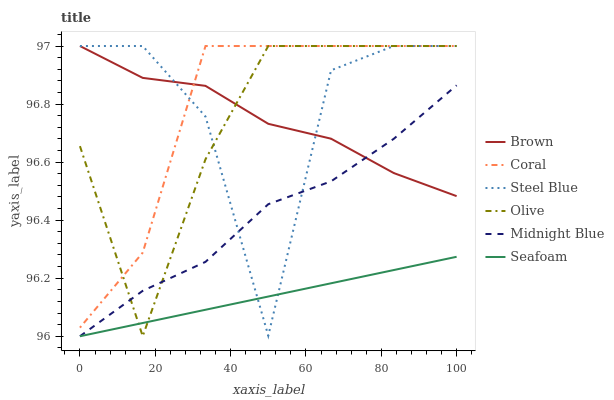Does Seafoam have the minimum area under the curve?
Answer yes or no. Yes. Does Coral have the maximum area under the curve?
Answer yes or no. Yes. Does Midnight Blue have the minimum area under the curve?
Answer yes or no. No. Does Midnight Blue have the maximum area under the curve?
Answer yes or no. No. Is Seafoam the smoothest?
Answer yes or no. Yes. Is Steel Blue the roughest?
Answer yes or no. Yes. Is Midnight Blue the smoothest?
Answer yes or no. No. Is Midnight Blue the roughest?
Answer yes or no. No. Does Midnight Blue have the lowest value?
Answer yes or no. Yes. Does Coral have the lowest value?
Answer yes or no. No. Does Olive have the highest value?
Answer yes or no. Yes. Does Midnight Blue have the highest value?
Answer yes or no. No. Is Seafoam less than Brown?
Answer yes or no. Yes. Is Coral greater than Seafoam?
Answer yes or no. Yes. Does Brown intersect Midnight Blue?
Answer yes or no. Yes. Is Brown less than Midnight Blue?
Answer yes or no. No. Is Brown greater than Midnight Blue?
Answer yes or no. No. Does Seafoam intersect Brown?
Answer yes or no. No. 